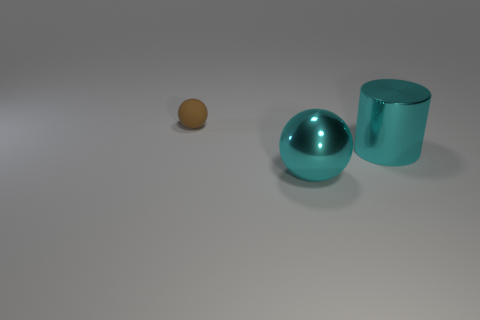Subtract all cyan spheres. How many spheres are left? 1 Subtract 1 spheres. How many spheres are left? 1 Subtract all cylinders. How many objects are left? 2 Add 2 brown matte spheres. How many objects exist? 5 Subtract all brown cubes. How many blue cylinders are left? 0 Subtract all metallic balls. Subtract all cyan metal balls. How many objects are left? 1 Add 2 big things. How many big things are left? 4 Add 3 small brown things. How many small brown things exist? 4 Subtract 0 yellow cylinders. How many objects are left? 3 Subtract all purple cylinders. Subtract all gray balls. How many cylinders are left? 1 